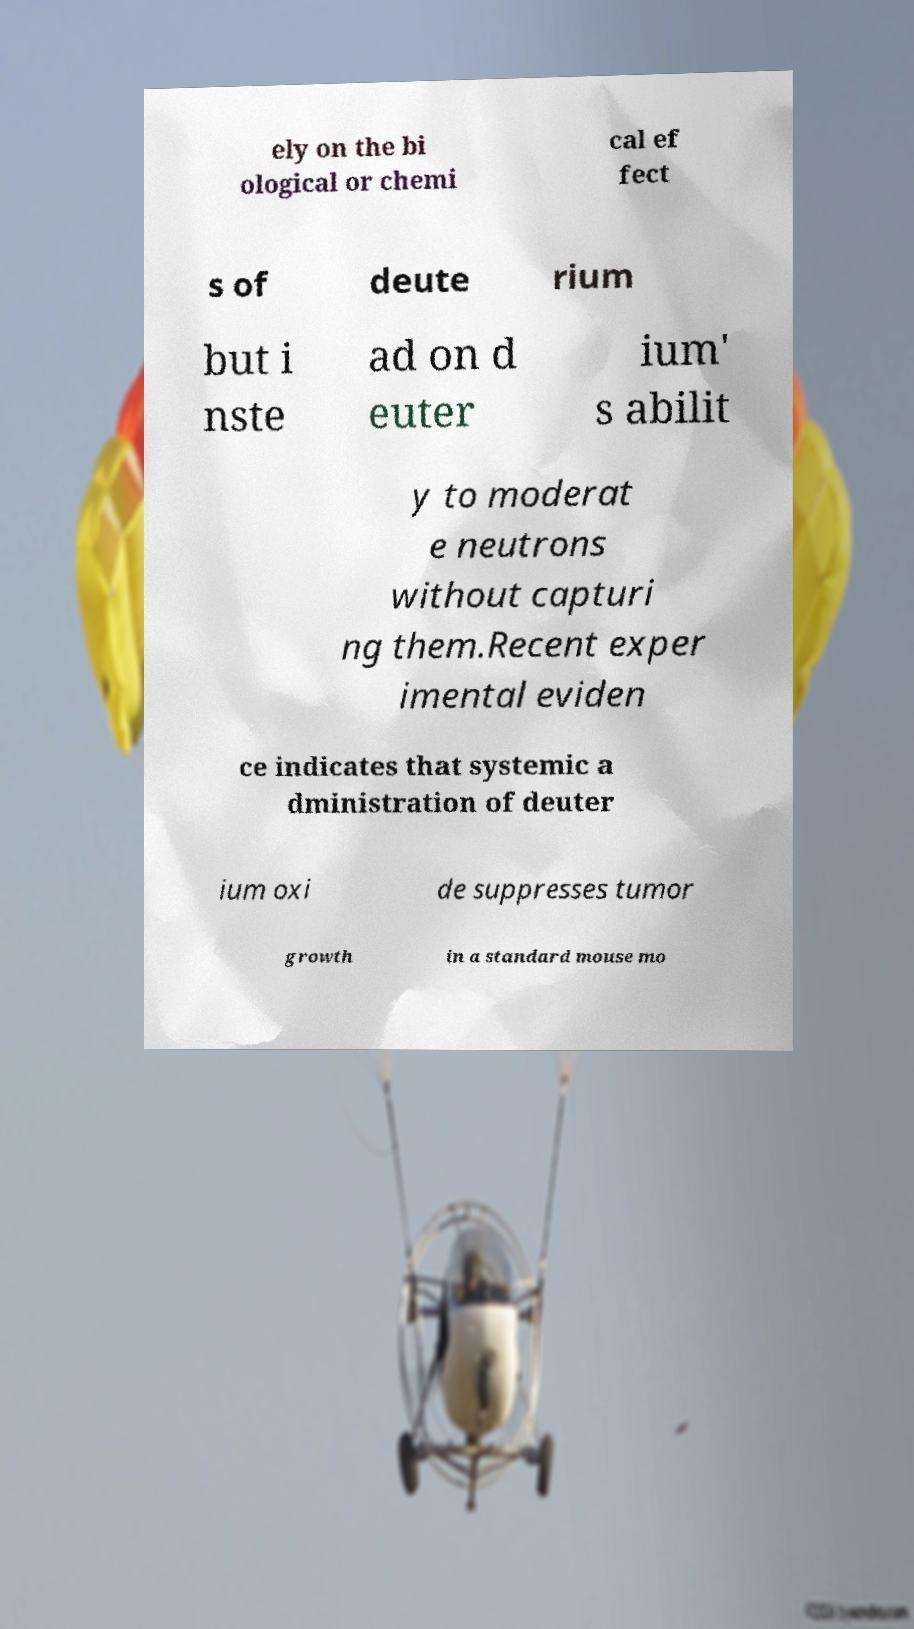Could you extract and type out the text from this image? ely on the bi ological or chemi cal ef fect s of deute rium but i nste ad on d euter ium' s abilit y to moderat e neutrons without capturi ng them.Recent exper imental eviden ce indicates that systemic a dministration of deuter ium oxi de suppresses tumor growth in a standard mouse mo 